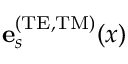Convert formula to latex. <formula><loc_0><loc_0><loc_500><loc_500>{ e } _ { s } ^ { ( T E , T M ) } ( x )</formula> 